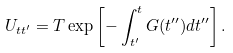Convert formula to latex. <formula><loc_0><loc_0><loc_500><loc_500>U _ { t t ^ { \prime } } = T \exp \left [ - \int _ { t ^ { \prime } } ^ { t } G ( t ^ { \prime \prime } ) d t ^ { \prime \prime } \right ] .</formula> 